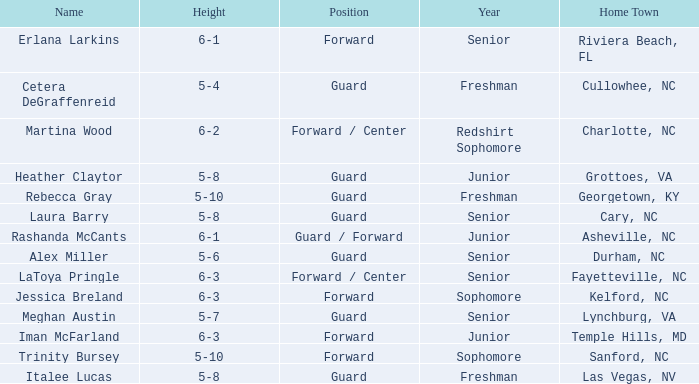What position does the 5-8 player from Grottoes, VA play? Guard. 